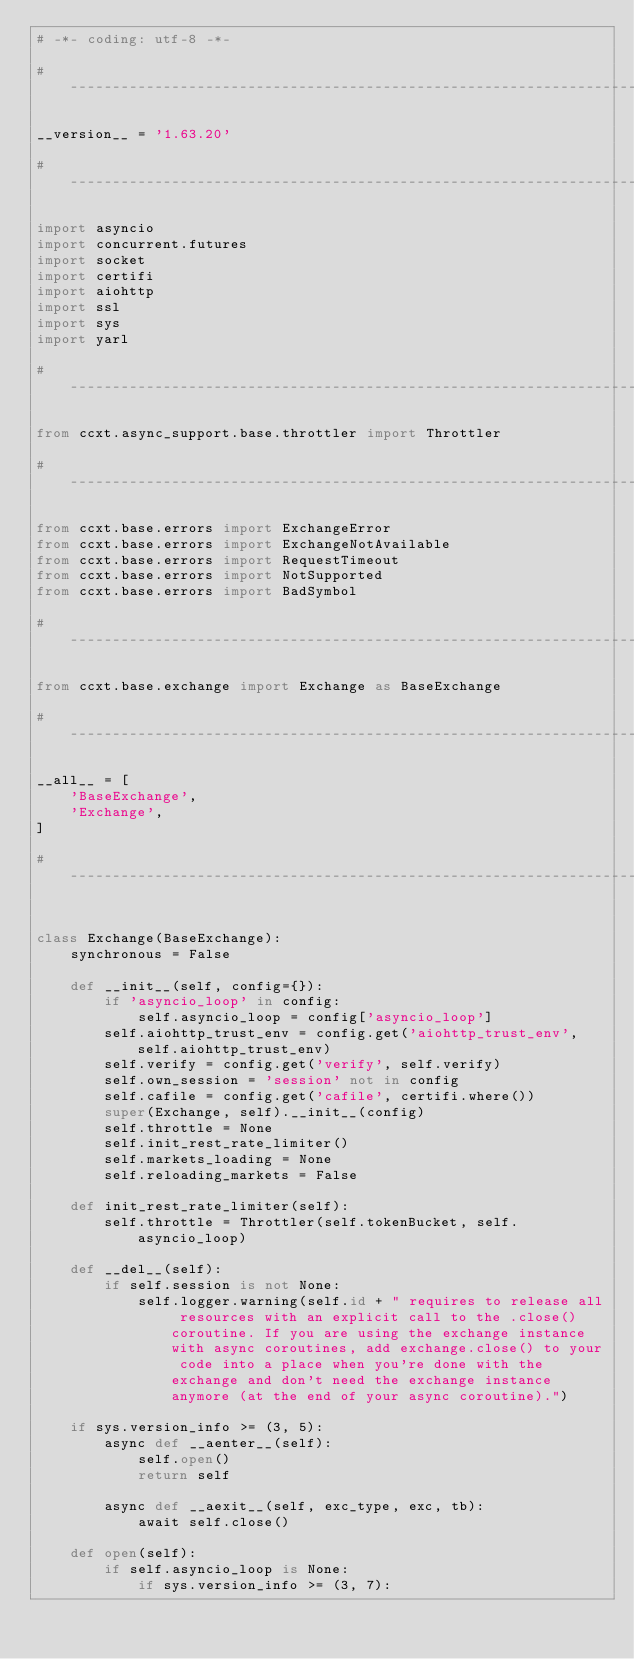<code> <loc_0><loc_0><loc_500><loc_500><_Python_># -*- coding: utf-8 -*-

# -----------------------------------------------------------------------------

__version__ = '1.63.20'

# -----------------------------------------------------------------------------

import asyncio
import concurrent.futures
import socket
import certifi
import aiohttp
import ssl
import sys
import yarl

# -----------------------------------------------------------------------------

from ccxt.async_support.base.throttler import Throttler

# -----------------------------------------------------------------------------

from ccxt.base.errors import ExchangeError
from ccxt.base.errors import ExchangeNotAvailable
from ccxt.base.errors import RequestTimeout
from ccxt.base.errors import NotSupported
from ccxt.base.errors import BadSymbol

# -----------------------------------------------------------------------------

from ccxt.base.exchange import Exchange as BaseExchange

# -----------------------------------------------------------------------------

__all__ = [
    'BaseExchange',
    'Exchange',
]

# -----------------------------------------------------------------------------


class Exchange(BaseExchange):
    synchronous = False

    def __init__(self, config={}):
        if 'asyncio_loop' in config:
            self.asyncio_loop = config['asyncio_loop']
        self.aiohttp_trust_env = config.get('aiohttp_trust_env', self.aiohttp_trust_env)
        self.verify = config.get('verify', self.verify)
        self.own_session = 'session' not in config
        self.cafile = config.get('cafile', certifi.where())
        super(Exchange, self).__init__(config)
        self.throttle = None
        self.init_rest_rate_limiter()
        self.markets_loading = None
        self.reloading_markets = False

    def init_rest_rate_limiter(self):
        self.throttle = Throttler(self.tokenBucket, self.asyncio_loop)

    def __del__(self):
        if self.session is not None:
            self.logger.warning(self.id + " requires to release all resources with an explicit call to the .close() coroutine. If you are using the exchange instance with async coroutines, add exchange.close() to your code into a place when you're done with the exchange and don't need the exchange instance anymore (at the end of your async coroutine).")

    if sys.version_info >= (3, 5):
        async def __aenter__(self):
            self.open()
            return self

        async def __aexit__(self, exc_type, exc, tb):
            await self.close()

    def open(self):
        if self.asyncio_loop is None:
            if sys.version_info >= (3, 7):</code> 